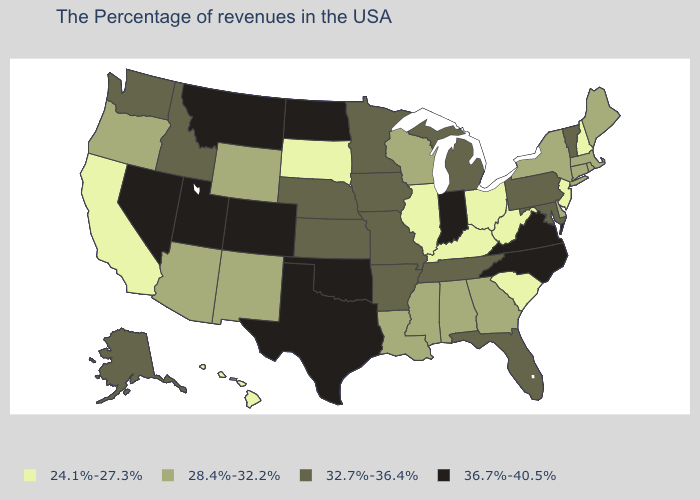Name the states that have a value in the range 28.4%-32.2%?
Give a very brief answer. Maine, Massachusetts, Rhode Island, Connecticut, New York, Delaware, Georgia, Alabama, Wisconsin, Mississippi, Louisiana, Wyoming, New Mexico, Arizona, Oregon. What is the lowest value in the West?
Give a very brief answer. 24.1%-27.3%. What is the value of North Carolina?
Concise answer only. 36.7%-40.5%. How many symbols are there in the legend?
Concise answer only. 4. Is the legend a continuous bar?
Short answer required. No. What is the value of Delaware?
Short answer required. 28.4%-32.2%. Does the first symbol in the legend represent the smallest category?
Write a very short answer. Yes. Name the states that have a value in the range 24.1%-27.3%?
Be succinct. New Hampshire, New Jersey, South Carolina, West Virginia, Ohio, Kentucky, Illinois, South Dakota, California, Hawaii. Does Virginia have the highest value in the USA?
Short answer required. Yes. Which states have the highest value in the USA?
Write a very short answer. Virginia, North Carolina, Indiana, Oklahoma, Texas, North Dakota, Colorado, Utah, Montana, Nevada. What is the lowest value in the South?
Give a very brief answer. 24.1%-27.3%. What is the value of Iowa?
Write a very short answer. 32.7%-36.4%. Name the states that have a value in the range 32.7%-36.4%?
Write a very short answer. Vermont, Maryland, Pennsylvania, Florida, Michigan, Tennessee, Missouri, Arkansas, Minnesota, Iowa, Kansas, Nebraska, Idaho, Washington, Alaska. Among the states that border Oklahoma , which have the lowest value?
Keep it brief. New Mexico. Does Kentucky have the lowest value in the USA?
Short answer required. Yes. 